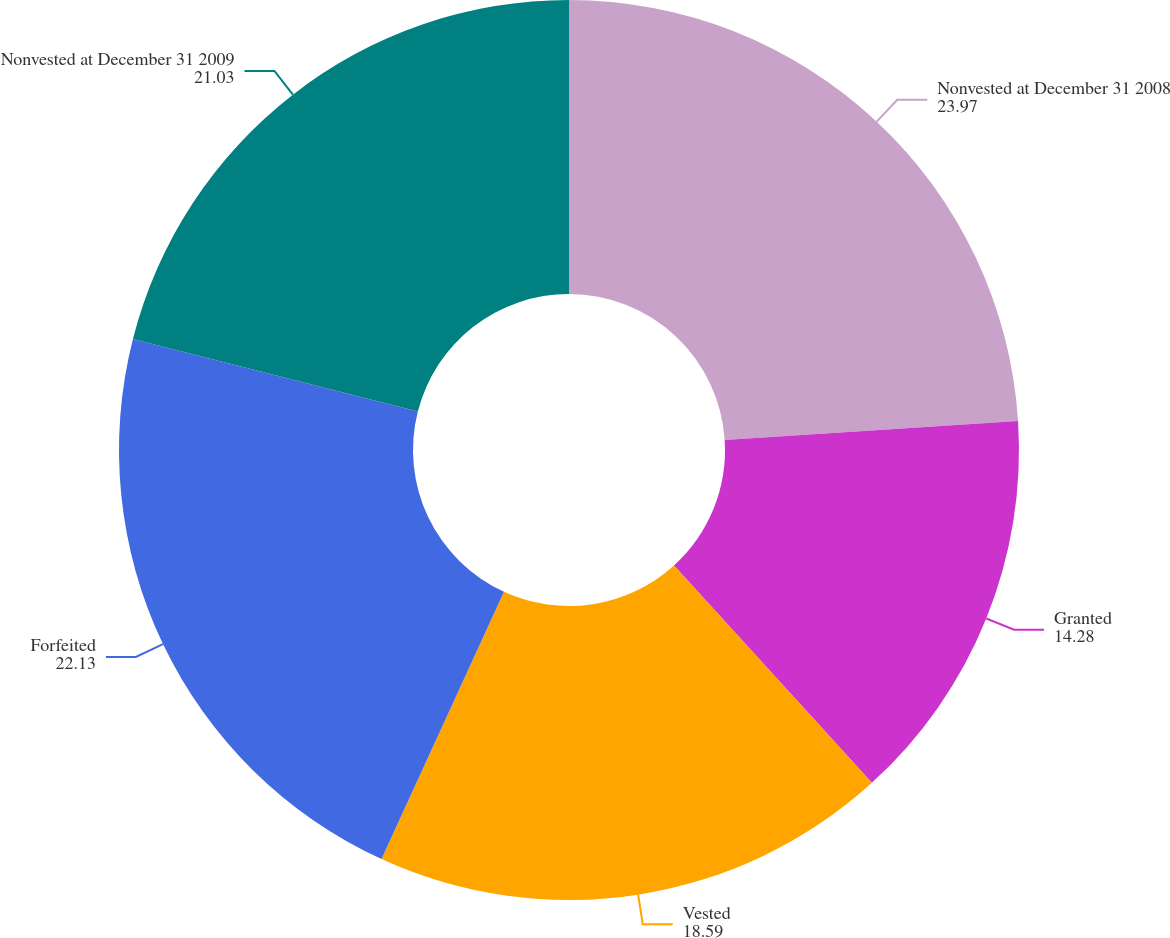<chart> <loc_0><loc_0><loc_500><loc_500><pie_chart><fcel>Nonvested at December 31 2008<fcel>Granted<fcel>Vested<fcel>Forfeited<fcel>Nonvested at December 31 2009<nl><fcel>23.97%<fcel>14.28%<fcel>18.59%<fcel>22.13%<fcel>21.03%<nl></chart> 